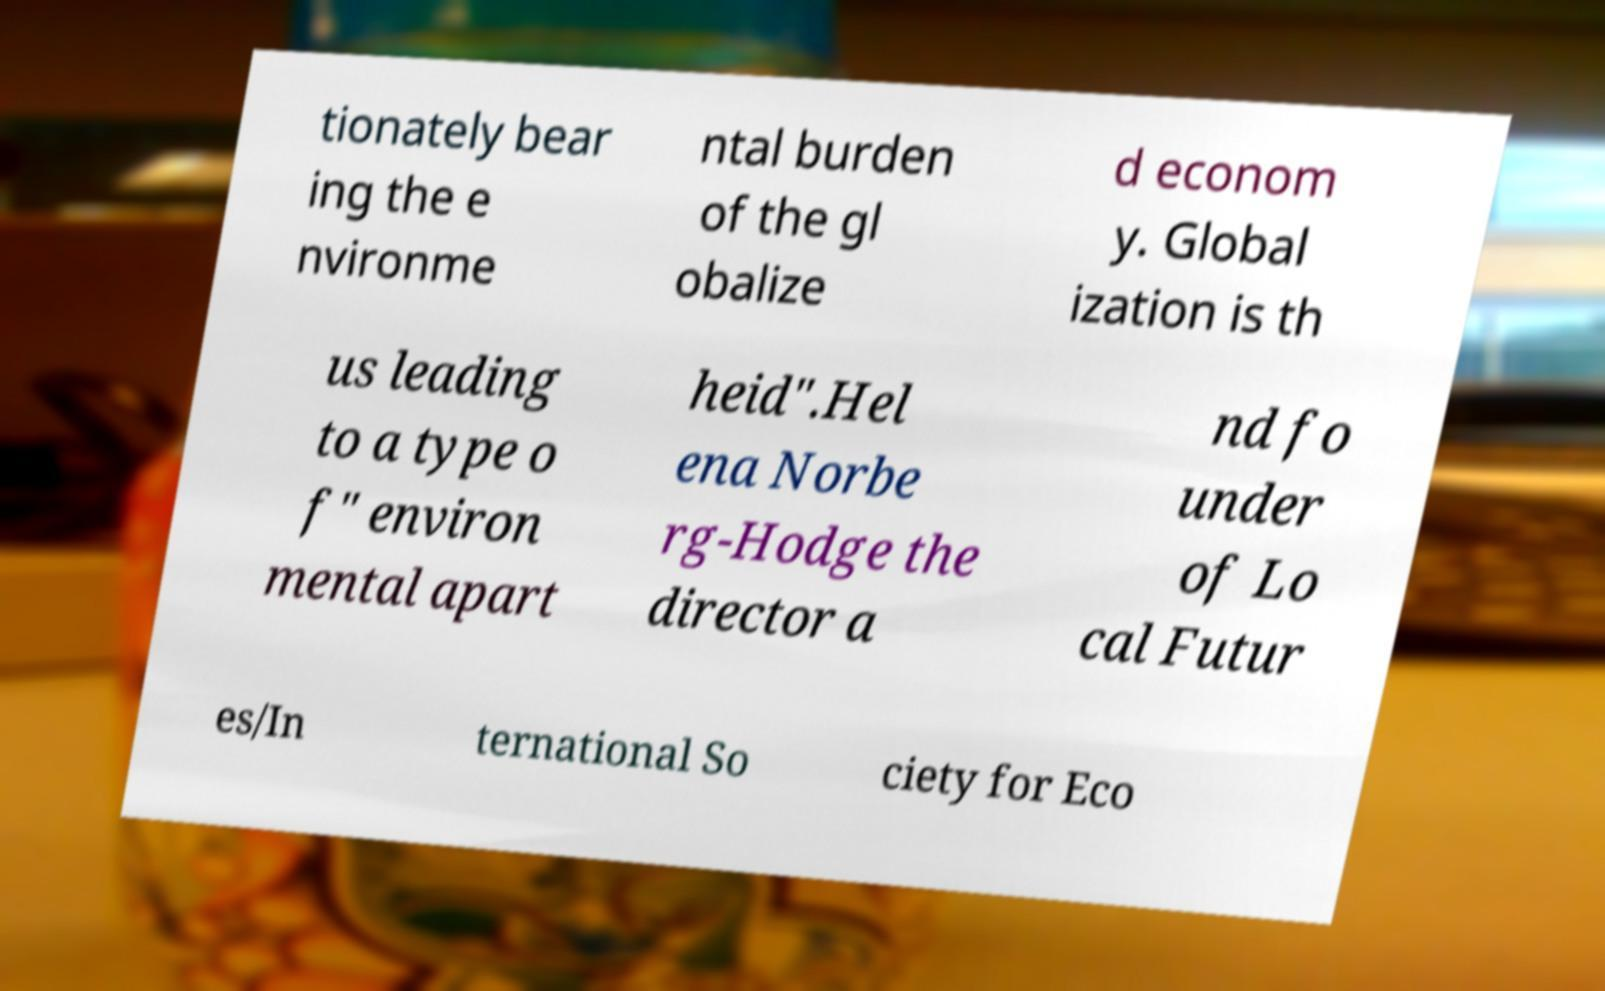For documentation purposes, I need the text within this image transcribed. Could you provide that? tionately bear ing the e nvironme ntal burden of the gl obalize d econom y. Global ization is th us leading to a type o f" environ mental apart heid".Hel ena Norbe rg-Hodge the director a nd fo under of Lo cal Futur es/In ternational So ciety for Eco 